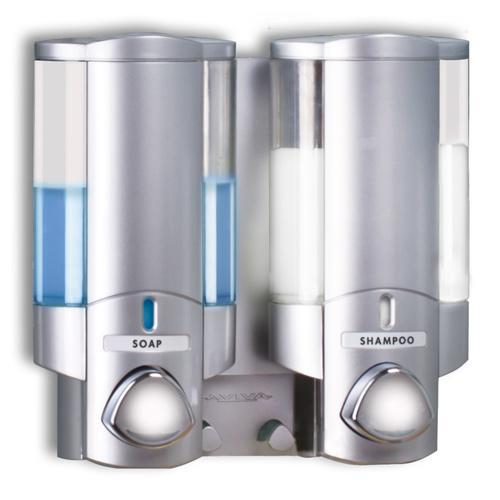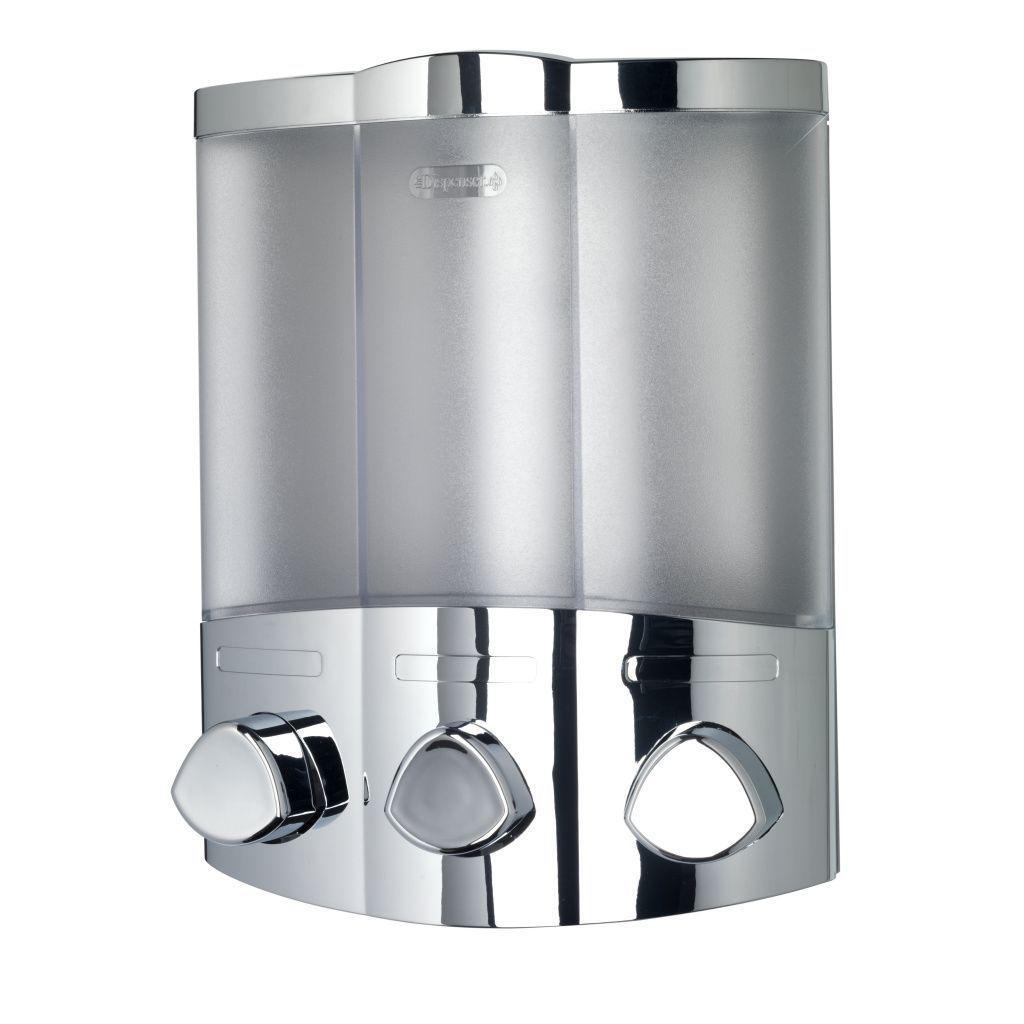The first image is the image on the left, the second image is the image on the right. Examine the images to the left and right. Is the description "All images include triple dispenser fixtures that mount on a wall, with the canisters close together side-by-side." accurate? Answer yes or no. No. 